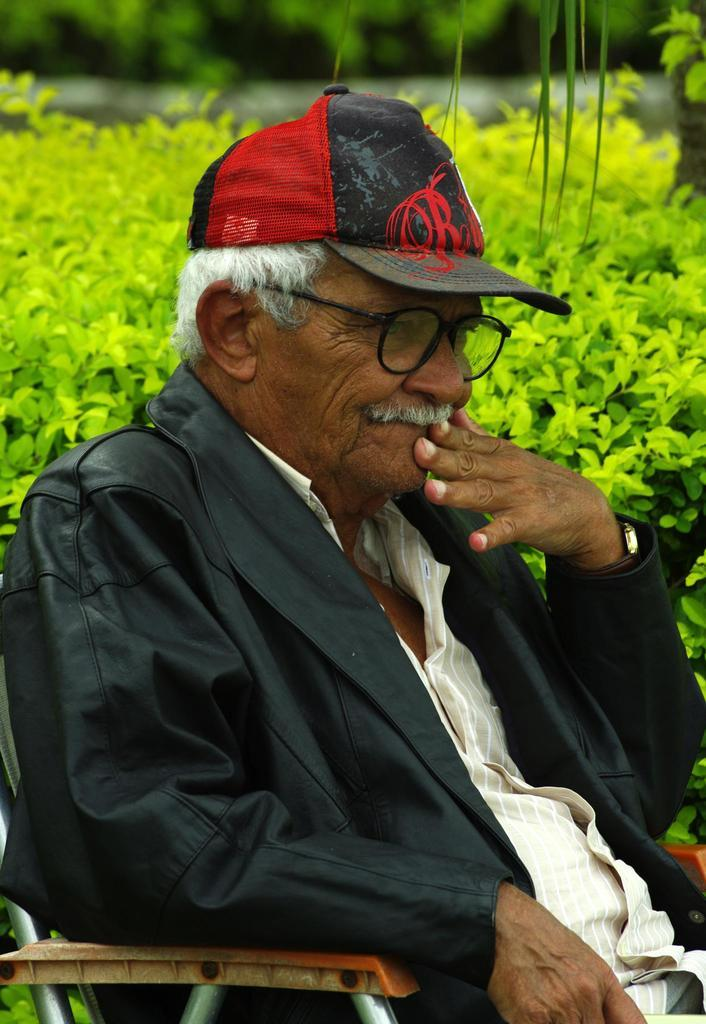Who is present in the image? There is a man in the image. What is the man wearing on his upper body? The man is wearing a black coat. What type of headwear is the man wearing? The man is wearing a cap. What is the man doing in the image? The man is sitting on a chair. Where is the chair located in the image? The chair is in the middle of the image. What can be seen in the background of the image? There are flower plants in the background of the image. What type of underwear is the man wearing in the image? There is no information about the man's underwear in the image, so we cannot determine what type he is wearing. How many clovers can be seen in the image? There are no clovers present in the image; it features a man sitting on a chair with flower plants in the background. 